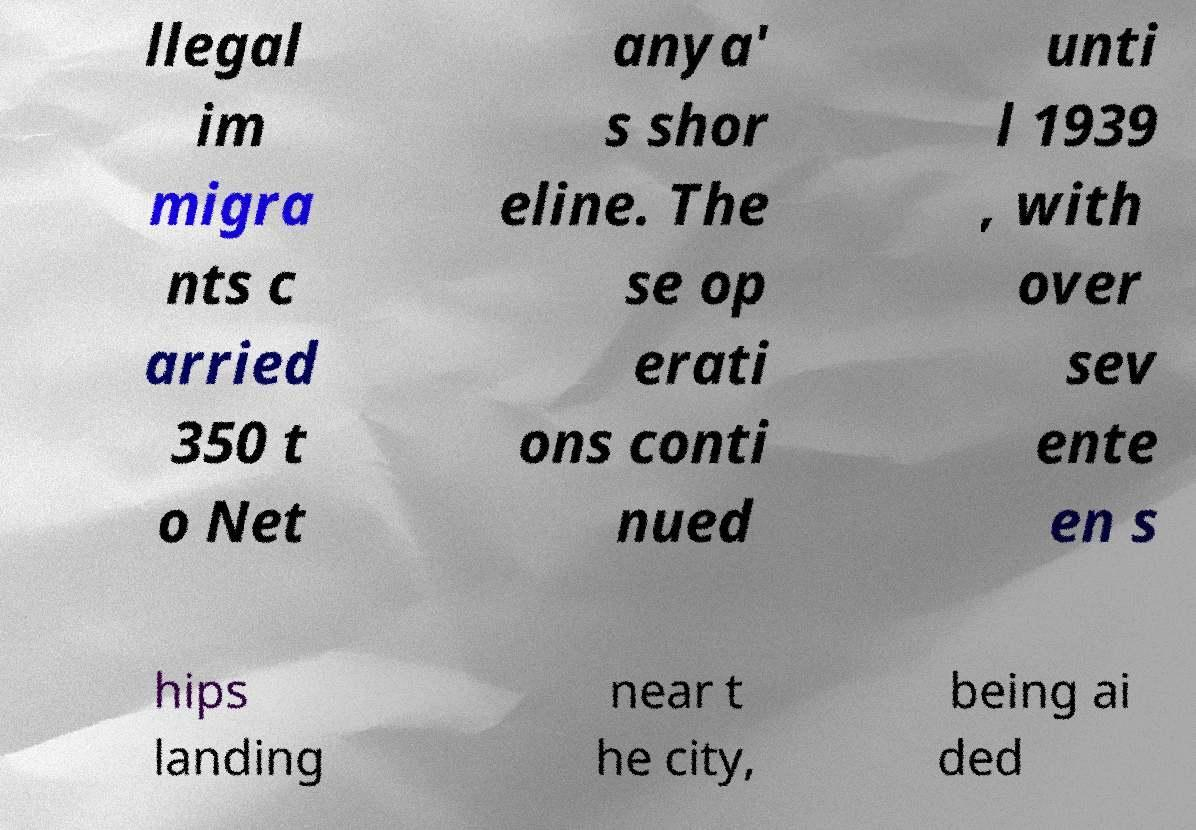Can you accurately transcribe the text from the provided image for me? llegal im migra nts c arried 350 t o Net anya' s shor eline. The se op erati ons conti nued unti l 1939 , with over sev ente en s hips landing near t he city, being ai ded 